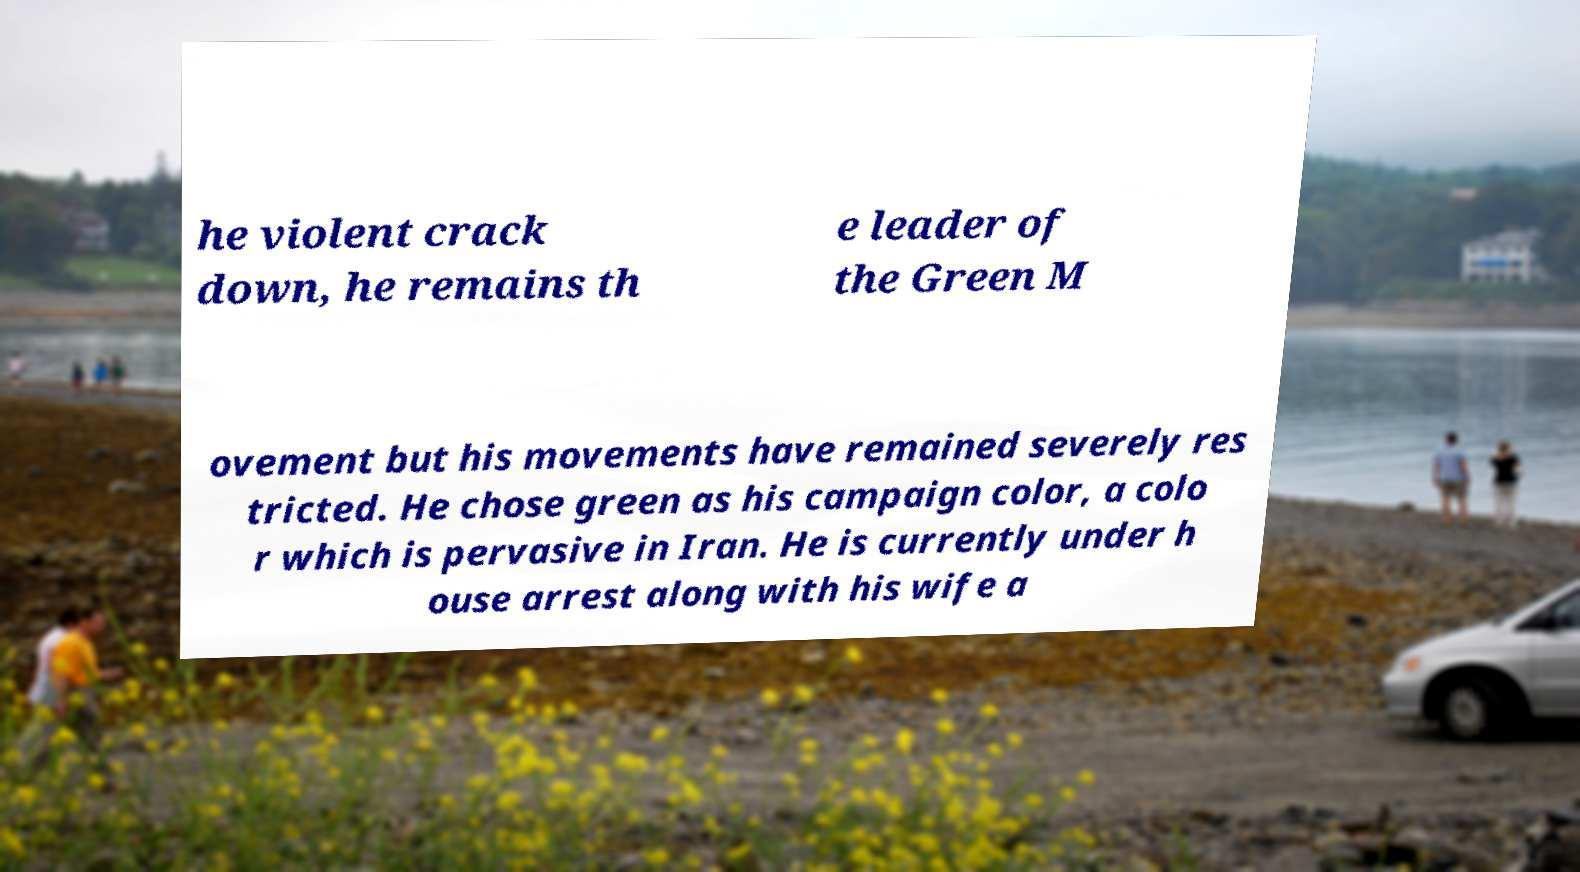Could you extract and type out the text from this image? he violent crack down, he remains th e leader of the Green M ovement but his movements have remained severely res tricted. He chose green as his campaign color, a colo r which is pervasive in Iran. He is currently under h ouse arrest along with his wife a 